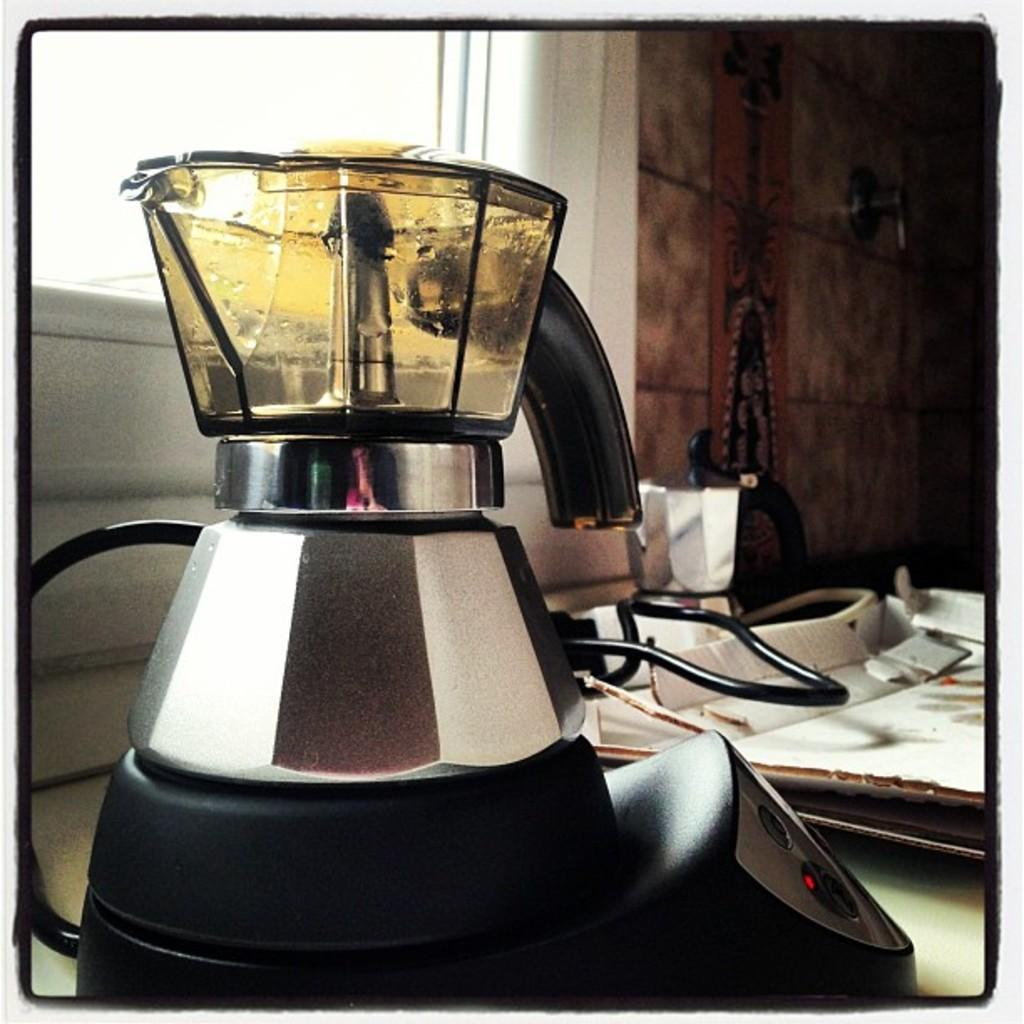What kitchen appliance is visible in the image? There is a mixer in the image. What is on top of the mixer? There is a jar on the mixer. What can be seen behind the mixer? There is a window behind the mixer. What is beside the window? There is a wall beside the window. What type of disease is being treated in the image? There is no indication of a disease or medical treatment in the image; it features a mixer with a jar on it and a window with a wall beside it. 